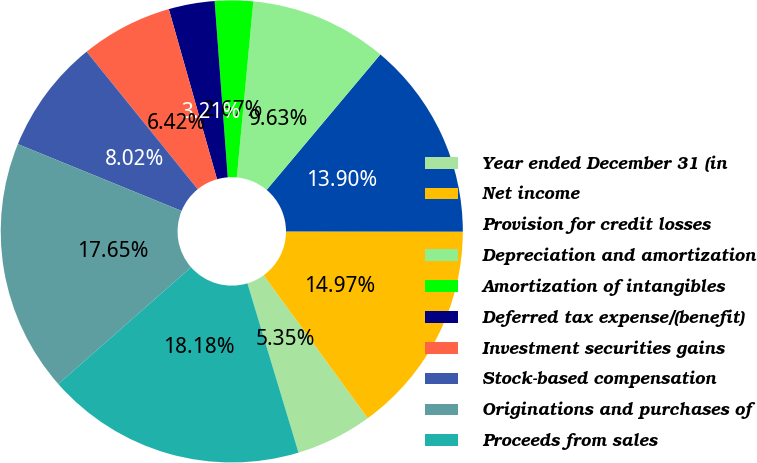<chart> <loc_0><loc_0><loc_500><loc_500><pie_chart><fcel>Year ended December 31 (in<fcel>Net income<fcel>Provision for credit losses<fcel>Depreciation and amortization<fcel>Amortization of intangibles<fcel>Deferred tax expense/(benefit)<fcel>Investment securities gains<fcel>Stock-based compensation<fcel>Originations and purchases of<fcel>Proceeds from sales<nl><fcel>5.35%<fcel>14.97%<fcel>13.9%<fcel>9.63%<fcel>2.67%<fcel>3.21%<fcel>6.42%<fcel>8.02%<fcel>17.65%<fcel>18.18%<nl></chart> 